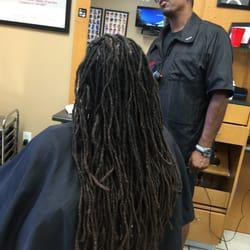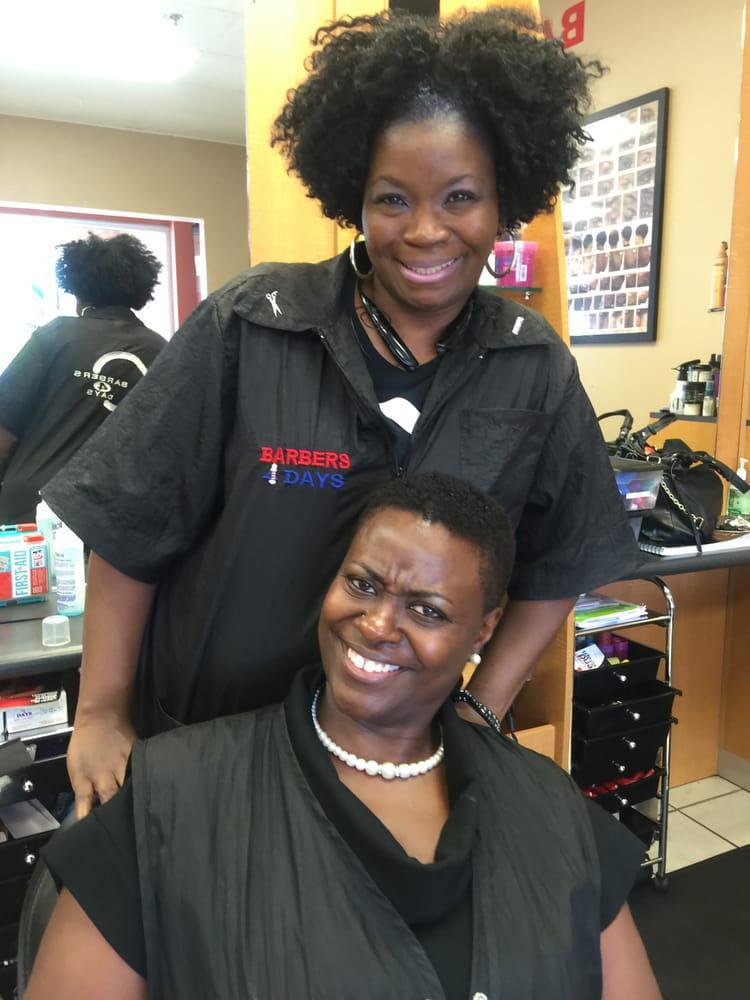The first image is the image on the left, the second image is the image on the right. For the images shown, is this caption "The left and right image contains the same number of people in the barber shop with at least one being a woman." true? Answer yes or no. Yes. 